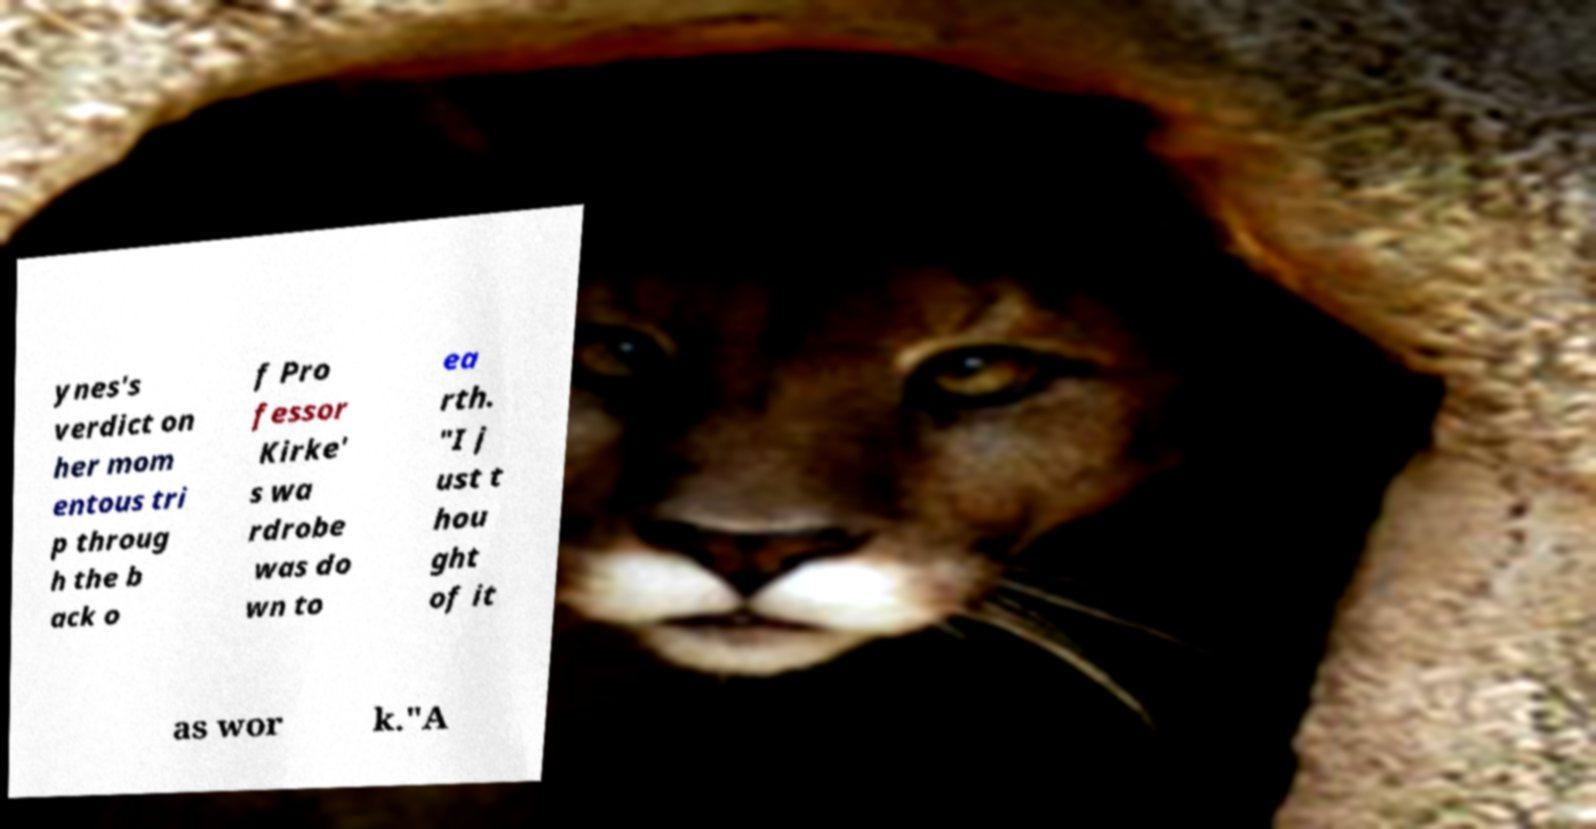Could you extract and type out the text from this image? ynes's verdict on her mom entous tri p throug h the b ack o f Pro fessor Kirke' s wa rdrobe was do wn to ea rth. "I j ust t hou ght of it as wor k."A 